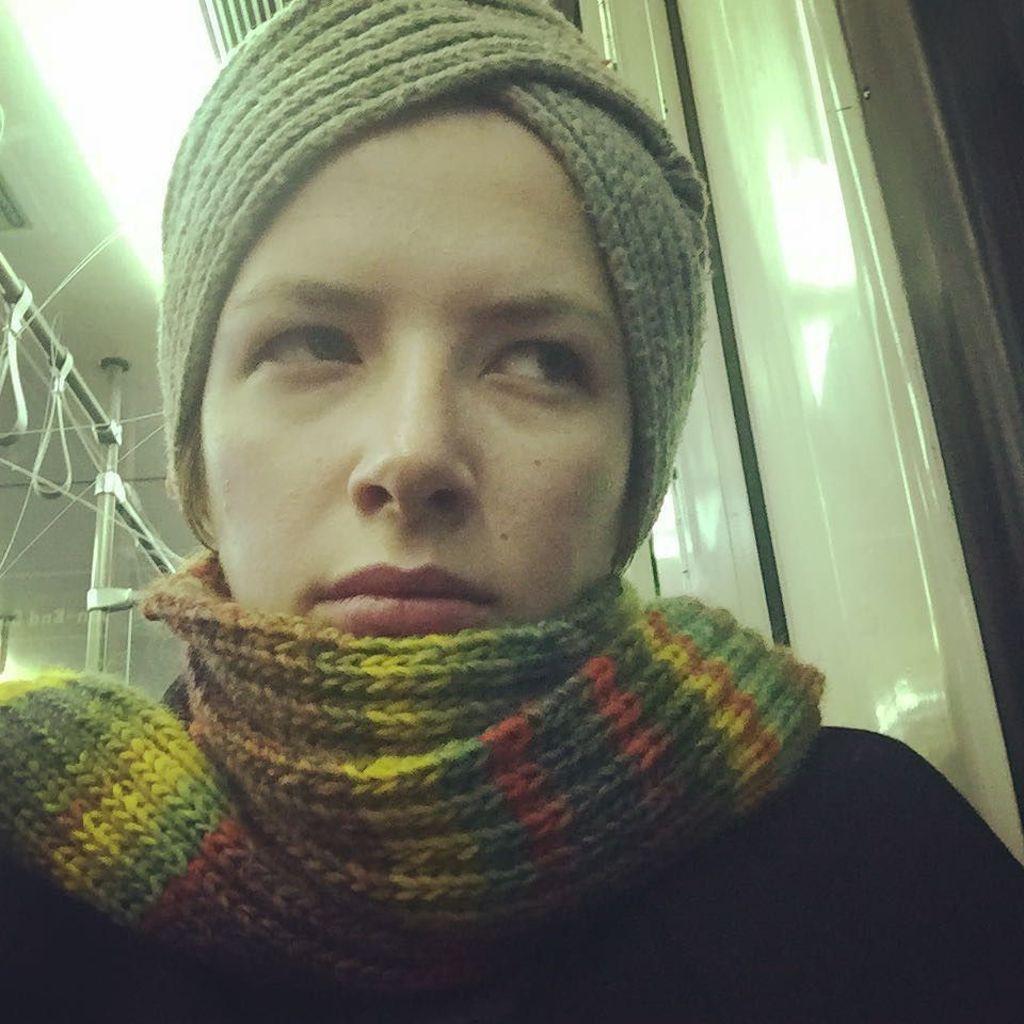Describe this image in one or two sentences. This person wore a scarf. These are rods. 